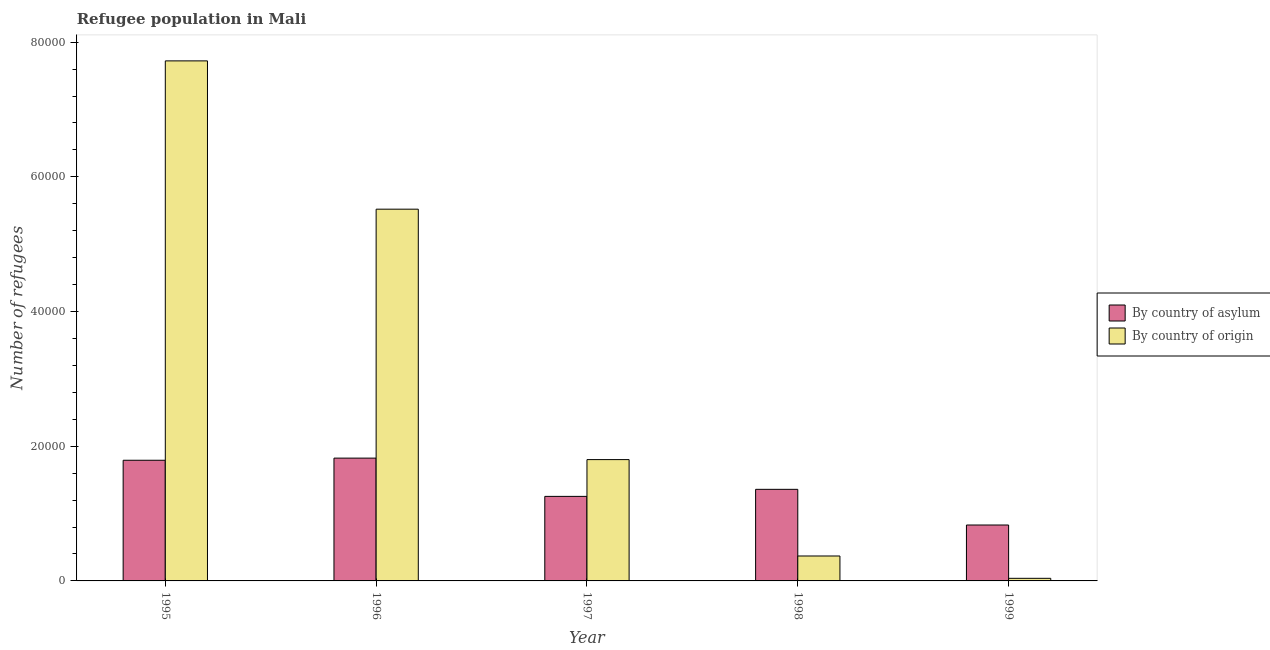How many different coloured bars are there?
Ensure brevity in your answer.  2. How many groups of bars are there?
Provide a short and direct response. 5. How many bars are there on the 5th tick from the left?
Make the answer very short. 2. How many bars are there on the 1st tick from the right?
Give a very brief answer. 2. In how many cases, is the number of bars for a given year not equal to the number of legend labels?
Your answer should be very brief. 0. What is the number of refugees by country of origin in 1998?
Offer a very short reply. 3702. Across all years, what is the maximum number of refugees by country of origin?
Your answer should be compact. 7.72e+04. Across all years, what is the minimum number of refugees by country of origin?
Provide a succinct answer. 387. What is the total number of refugees by country of origin in the graph?
Keep it short and to the point. 1.55e+05. What is the difference between the number of refugees by country of asylum in 1997 and that in 1998?
Your answer should be very brief. -1046. What is the difference between the number of refugees by country of origin in 1998 and the number of refugees by country of asylum in 1996?
Keep it short and to the point. -5.15e+04. What is the average number of refugees by country of asylum per year?
Offer a very short reply. 1.41e+04. In the year 1996, what is the difference between the number of refugees by country of origin and number of refugees by country of asylum?
Offer a terse response. 0. In how many years, is the number of refugees by country of origin greater than 36000?
Make the answer very short. 2. What is the ratio of the number of refugees by country of asylum in 1995 to that in 1999?
Your answer should be very brief. 2.16. Is the number of refugees by country of origin in 1995 less than that in 1997?
Make the answer very short. No. Is the difference between the number of refugees by country of origin in 1996 and 1999 greater than the difference between the number of refugees by country of asylum in 1996 and 1999?
Keep it short and to the point. No. What is the difference between the highest and the second highest number of refugees by country of origin?
Ensure brevity in your answer.  2.20e+04. What is the difference between the highest and the lowest number of refugees by country of origin?
Your response must be concise. 7.68e+04. In how many years, is the number of refugees by country of origin greater than the average number of refugees by country of origin taken over all years?
Give a very brief answer. 2. What does the 2nd bar from the left in 1999 represents?
Your answer should be very brief. By country of origin. What does the 1st bar from the right in 1997 represents?
Ensure brevity in your answer.  By country of origin. How many bars are there?
Make the answer very short. 10. Are all the bars in the graph horizontal?
Your response must be concise. No. What is the difference between two consecutive major ticks on the Y-axis?
Offer a very short reply. 2.00e+04. Where does the legend appear in the graph?
Keep it short and to the point. Center right. How many legend labels are there?
Your answer should be compact. 2. How are the legend labels stacked?
Keep it short and to the point. Vertical. What is the title of the graph?
Give a very brief answer. Refugee population in Mali. What is the label or title of the X-axis?
Offer a terse response. Year. What is the label or title of the Y-axis?
Offer a terse response. Number of refugees. What is the Number of refugees in By country of asylum in 1995?
Your answer should be compact. 1.79e+04. What is the Number of refugees in By country of origin in 1995?
Offer a very short reply. 7.72e+04. What is the Number of refugees in By country of asylum in 1996?
Keep it short and to the point. 1.82e+04. What is the Number of refugees of By country of origin in 1996?
Ensure brevity in your answer.  5.52e+04. What is the Number of refugees of By country of asylum in 1997?
Your answer should be very brief. 1.26e+04. What is the Number of refugees in By country of origin in 1997?
Your answer should be compact. 1.80e+04. What is the Number of refugees in By country of asylum in 1998?
Keep it short and to the point. 1.36e+04. What is the Number of refugees of By country of origin in 1998?
Provide a short and direct response. 3702. What is the Number of refugees of By country of asylum in 1999?
Your answer should be compact. 8302. What is the Number of refugees in By country of origin in 1999?
Offer a terse response. 387. Across all years, what is the maximum Number of refugees of By country of asylum?
Your answer should be compact. 1.82e+04. Across all years, what is the maximum Number of refugees of By country of origin?
Your response must be concise. 7.72e+04. Across all years, what is the minimum Number of refugees in By country of asylum?
Your answer should be compact. 8302. Across all years, what is the minimum Number of refugees in By country of origin?
Provide a short and direct response. 387. What is the total Number of refugees of By country of asylum in the graph?
Your answer should be compact. 7.06e+04. What is the total Number of refugees of By country of origin in the graph?
Your answer should be very brief. 1.55e+05. What is the difference between the Number of refugees of By country of asylum in 1995 and that in 1996?
Provide a short and direct response. -318. What is the difference between the Number of refugees of By country of origin in 1995 and that in 1996?
Ensure brevity in your answer.  2.20e+04. What is the difference between the Number of refugees in By country of asylum in 1995 and that in 1997?
Make the answer very short. 5364. What is the difference between the Number of refugees of By country of origin in 1995 and that in 1997?
Give a very brief answer. 5.92e+04. What is the difference between the Number of refugees of By country of asylum in 1995 and that in 1998?
Your answer should be compact. 4318. What is the difference between the Number of refugees of By country of origin in 1995 and that in 1998?
Your answer should be very brief. 7.35e+04. What is the difference between the Number of refugees of By country of asylum in 1995 and that in 1999?
Your answer should be compact. 9614. What is the difference between the Number of refugees of By country of origin in 1995 and that in 1999?
Keep it short and to the point. 7.68e+04. What is the difference between the Number of refugees in By country of asylum in 1996 and that in 1997?
Make the answer very short. 5682. What is the difference between the Number of refugees of By country of origin in 1996 and that in 1997?
Provide a short and direct response. 3.72e+04. What is the difference between the Number of refugees of By country of asylum in 1996 and that in 1998?
Offer a very short reply. 4636. What is the difference between the Number of refugees in By country of origin in 1996 and that in 1998?
Your answer should be very brief. 5.15e+04. What is the difference between the Number of refugees of By country of asylum in 1996 and that in 1999?
Keep it short and to the point. 9932. What is the difference between the Number of refugees of By country of origin in 1996 and that in 1999?
Your answer should be compact. 5.48e+04. What is the difference between the Number of refugees in By country of asylum in 1997 and that in 1998?
Your answer should be very brief. -1046. What is the difference between the Number of refugees in By country of origin in 1997 and that in 1998?
Provide a succinct answer. 1.43e+04. What is the difference between the Number of refugees of By country of asylum in 1997 and that in 1999?
Provide a succinct answer. 4250. What is the difference between the Number of refugees in By country of origin in 1997 and that in 1999?
Your response must be concise. 1.76e+04. What is the difference between the Number of refugees in By country of asylum in 1998 and that in 1999?
Your answer should be compact. 5296. What is the difference between the Number of refugees of By country of origin in 1998 and that in 1999?
Your answer should be very brief. 3315. What is the difference between the Number of refugees of By country of asylum in 1995 and the Number of refugees of By country of origin in 1996?
Offer a very short reply. -3.73e+04. What is the difference between the Number of refugees in By country of asylum in 1995 and the Number of refugees in By country of origin in 1997?
Offer a terse response. -99. What is the difference between the Number of refugees of By country of asylum in 1995 and the Number of refugees of By country of origin in 1998?
Provide a succinct answer. 1.42e+04. What is the difference between the Number of refugees of By country of asylum in 1995 and the Number of refugees of By country of origin in 1999?
Give a very brief answer. 1.75e+04. What is the difference between the Number of refugees in By country of asylum in 1996 and the Number of refugees in By country of origin in 1997?
Your answer should be compact. 219. What is the difference between the Number of refugees in By country of asylum in 1996 and the Number of refugees in By country of origin in 1998?
Provide a succinct answer. 1.45e+04. What is the difference between the Number of refugees of By country of asylum in 1996 and the Number of refugees of By country of origin in 1999?
Offer a terse response. 1.78e+04. What is the difference between the Number of refugees of By country of asylum in 1997 and the Number of refugees of By country of origin in 1998?
Ensure brevity in your answer.  8850. What is the difference between the Number of refugees of By country of asylum in 1997 and the Number of refugees of By country of origin in 1999?
Make the answer very short. 1.22e+04. What is the difference between the Number of refugees in By country of asylum in 1998 and the Number of refugees in By country of origin in 1999?
Ensure brevity in your answer.  1.32e+04. What is the average Number of refugees of By country of asylum per year?
Provide a short and direct response. 1.41e+04. What is the average Number of refugees in By country of origin per year?
Ensure brevity in your answer.  3.09e+04. In the year 1995, what is the difference between the Number of refugees in By country of asylum and Number of refugees in By country of origin?
Offer a terse response. -5.93e+04. In the year 1996, what is the difference between the Number of refugees of By country of asylum and Number of refugees of By country of origin?
Make the answer very short. -3.70e+04. In the year 1997, what is the difference between the Number of refugees in By country of asylum and Number of refugees in By country of origin?
Offer a very short reply. -5463. In the year 1998, what is the difference between the Number of refugees in By country of asylum and Number of refugees in By country of origin?
Offer a very short reply. 9896. In the year 1999, what is the difference between the Number of refugees in By country of asylum and Number of refugees in By country of origin?
Provide a short and direct response. 7915. What is the ratio of the Number of refugees of By country of asylum in 1995 to that in 1996?
Give a very brief answer. 0.98. What is the ratio of the Number of refugees in By country of origin in 1995 to that in 1996?
Make the answer very short. 1.4. What is the ratio of the Number of refugees of By country of asylum in 1995 to that in 1997?
Ensure brevity in your answer.  1.43. What is the ratio of the Number of refugees in By country of origin in 1995 to that in 1997?
Your answer should be very brief. 4.29. What is the ratio of the Number of refugees of By country of asylum in 1995 to that in 1998?
Make the answer very short. 1.32. What is the ratio of the Number of refugees of By country of origin in 1995 to that in 1998?
Provide a short and direct response. 20.86. What is the ratio of the Number of refugees in By country of asylum in 1995 to that in 1999?
Provide a short and direct response. 2.16. What is the ratio of the Number of refugees in By country of origin in 1995 to that in 1999?
Offer a terse response. 199.53. What is the ratio of the Number of refugees in By country of asylum in 1996 to that in 1997?
Keep it short and to the point. 1.45. What is the ratio of the Number of refugees in By country of origin in 1996 to that in 1997?
Your answer should be compact. 3.06. What is the ratio of the Number of refugees in By country of asylum in 1996 to that in 1998?
Give a very brief answer. 1.34. What is the ratio of the Number of refugees of By country of origin in 1996 to that in 1998?
Your answer should be compact. 14.91. What is the ratio of the Number of refugees of By country of asylum in 1996 to that in 1999?
Make the answer very short. 2.2. What is the ratio of the Number of refugees in By country of origin in 1996 to that in 1999?
Ensure brevity in your answer.  142.63. What is the ratio of the Number of refugees of By country of asylum in 1997 to that in 1998?
Offer a very short reply. 0.92. What is the ratio of the Number of refugees in By country of origin in 1997 to that in 1998?
Your answer should be very brief. 4.87. What is the ratio of the Number of refugees of By country of asylum in 1997 to that in 1999?
Your answer should be compact. 1.51. What is the ratio of the Number of refugees in By country of origin in 1997 to that in 1999?
Ensure brevity in your answer.  46.55. What is the ratio of the Number of refugees in By country of asylum in 1998 to that in 1999?
Provide a succinct answer. 1.64. What is the ratio of the Number of refugees in By country of origin in 1998 to that in 1999?
Offer a terse response. 9.57. What is the difference between the highest and the second highest Number of refugees of By country of asylum?
Your answer should be very brief. 318. What is the difference between the highest and the second highest Number of refugees of By country of origin?
Keep it short and to the point. 2.20e+04. What is the difference between the highest and the lowest Number of refugees in By country of asylum?
Your answer should be very brief. 9932. What is the difference between the highest and the lowest Number of refugees of By country of origin?
Give a very brief answer. 7.68e+04. 